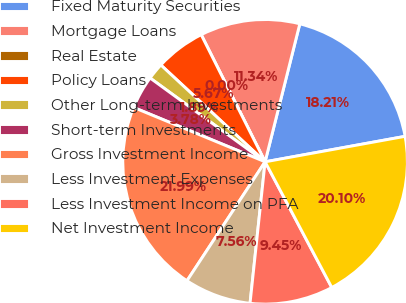Convert chart. <chart><loc_0><loc_0><loc_500><loc_500><pie_chart><fcel>Fixed Maturity Securities<fcel>Mortgage Loans<fcel>Real Estate<fcel>Policy Loans<fcel>Other Long-term Investments<fcel>Short-term Investments<fcel>Gross Investment Income<fcel>Less Investment Expenses<fcel>Less Investment Income on PFA<fcel>Net Investment Income<nl><fcel>18.21%<fcel>11.34%<fcel>0.0%<fcel>5.67%<fcel>1.89%<fcel>3.78%<fcel>21.99%<fcel>7.56%<fcel>9.45%<fcel>20.1%<nl></chart> 